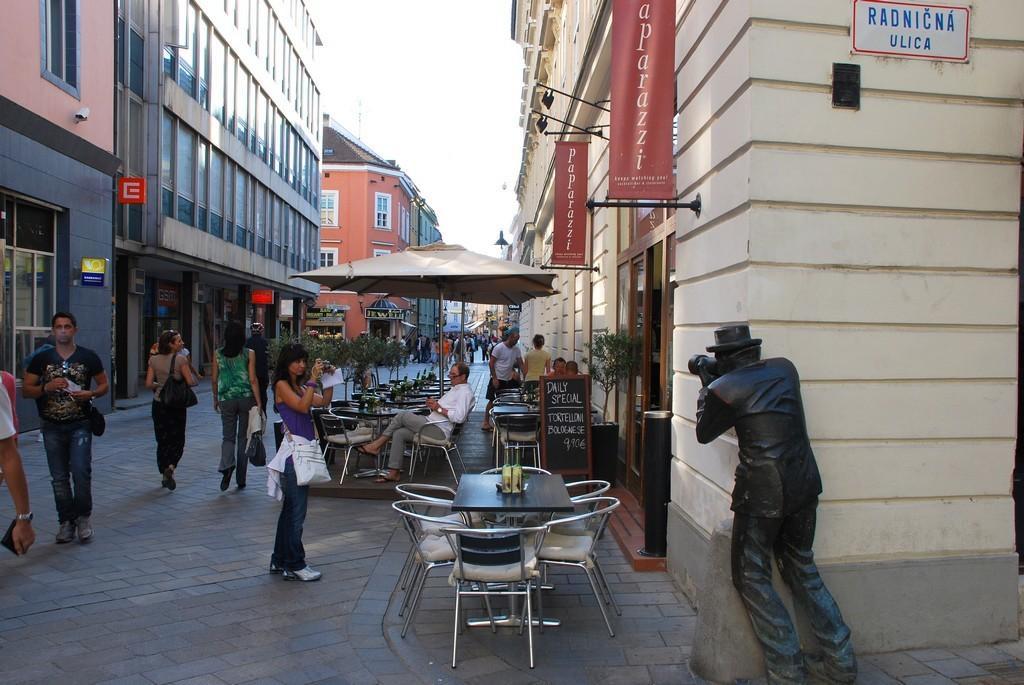Please provide a concise description of this image. In this picture we can see some group of people where some are walking on road and here woman taking picture of statue and some are sitting on chair and here it is umbrella and in background we can see building with windows, banners and on table we can see some bottles. 